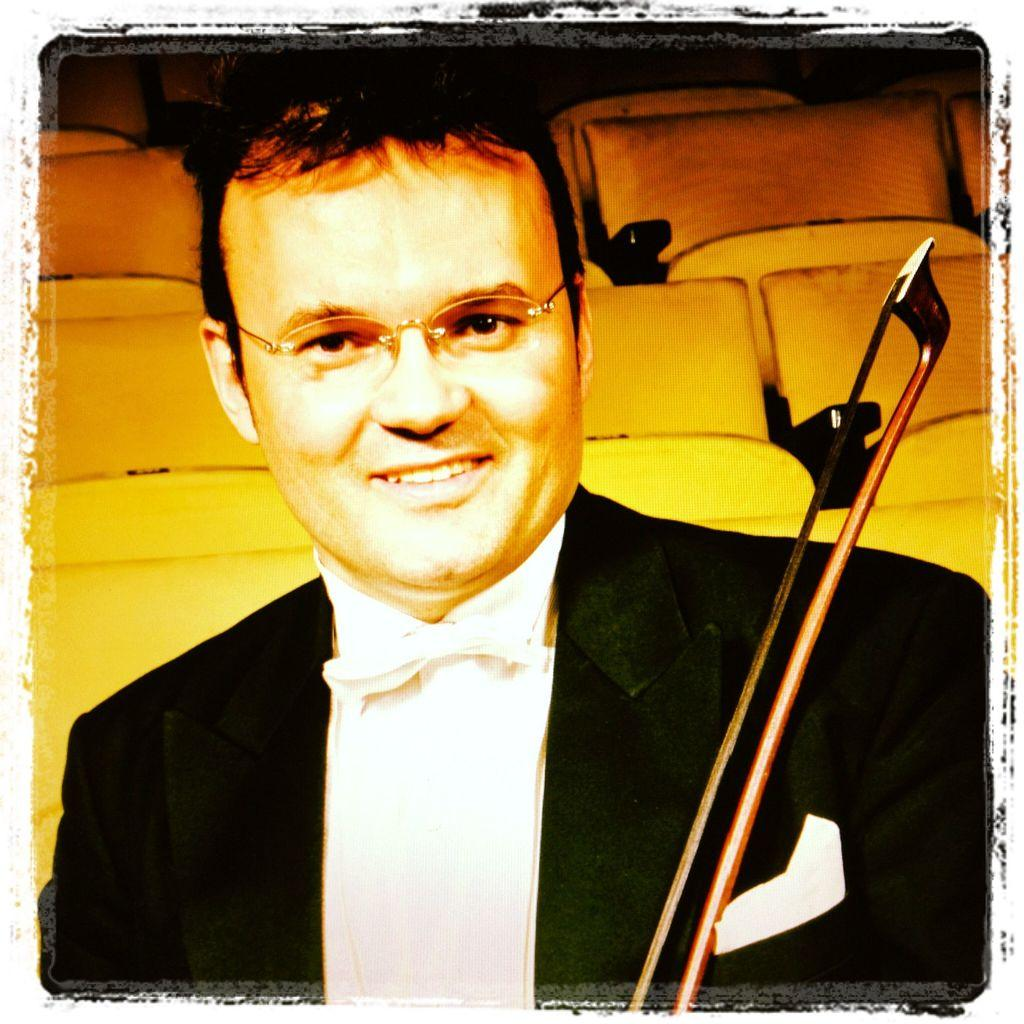What feature is present around the edges of the image? The image has borders. What is the person in the foreground wearing? There is a person wearing a suit in the foreground. What can be seen in the foreground besides the person? There is an object visible in the foreground. What type of furniture is present in the background? There are chairs in the background. How many planes can be seen flying in the image? There are no planes visible in the image. What type of root is growing near the person in the foreground? There is no root present in the image. 